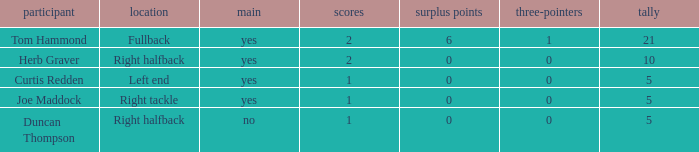Name the most touchdowns for field goals being 1 2.0. 